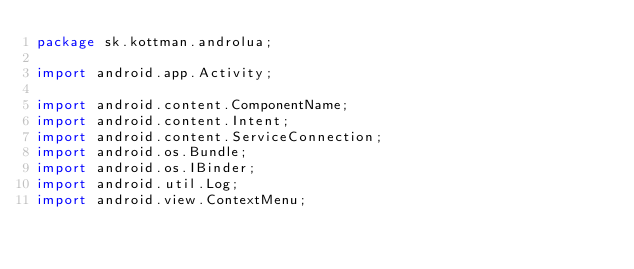<code> <loc_0><loc_0><loc_500><loc_500><_Java_>package sk.kottman.androlua;

import android.app.Activity;

import android.content.ComponentName;
import android.content.Intent;
import android.content.ServiceConnection;
import android.os.Bundle;
import android.os.IBinder;
import android.util.Log;
import android.view.ContextMenu;</code> 